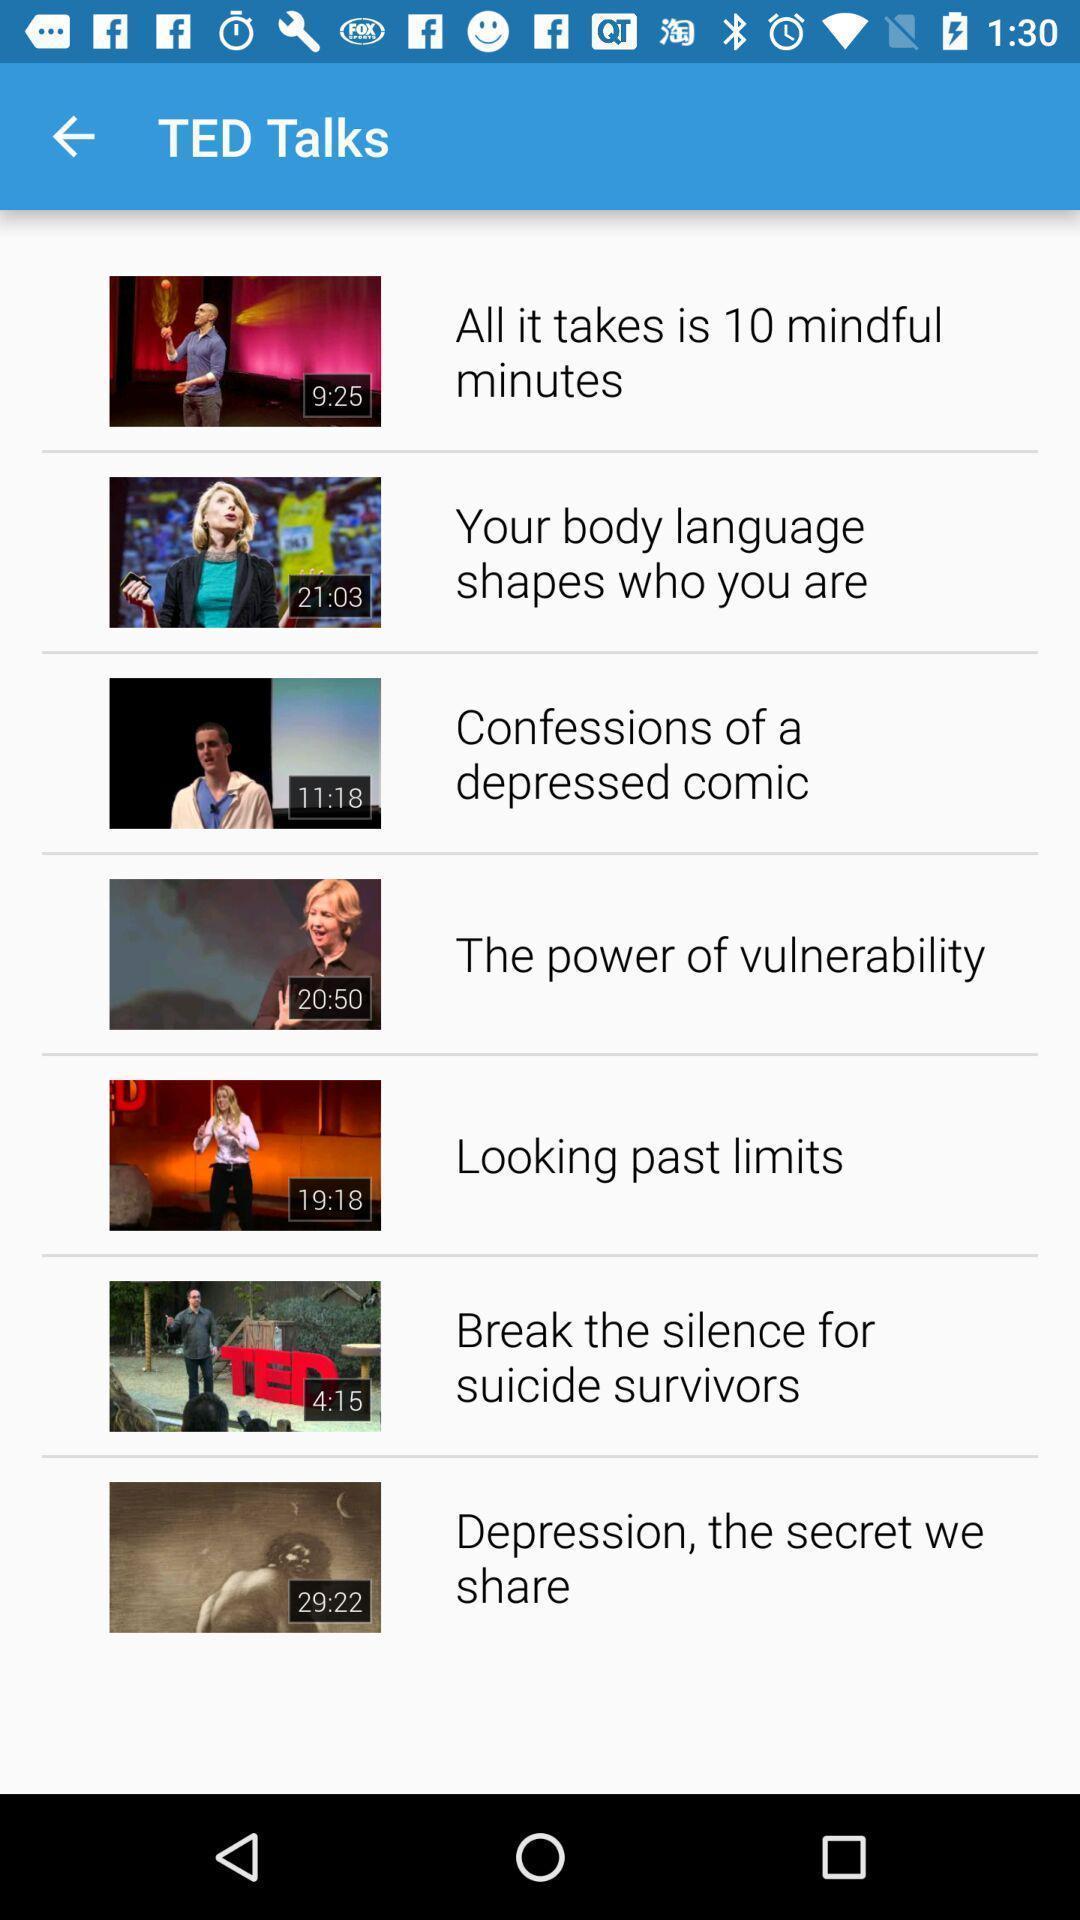Explain what's happening in this screen capture. Screen shows list of videos in a talk app. 